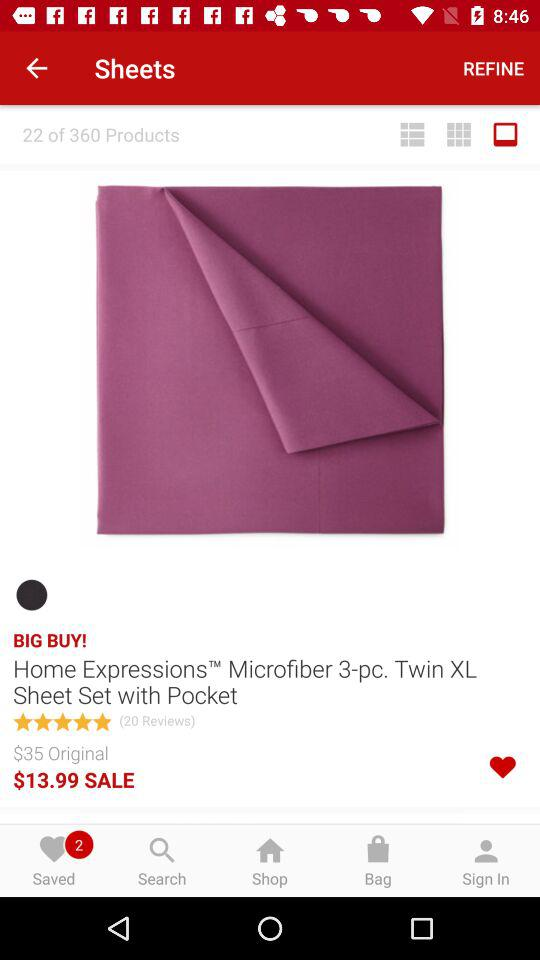How many saved items are there? There are 2 saved items. 